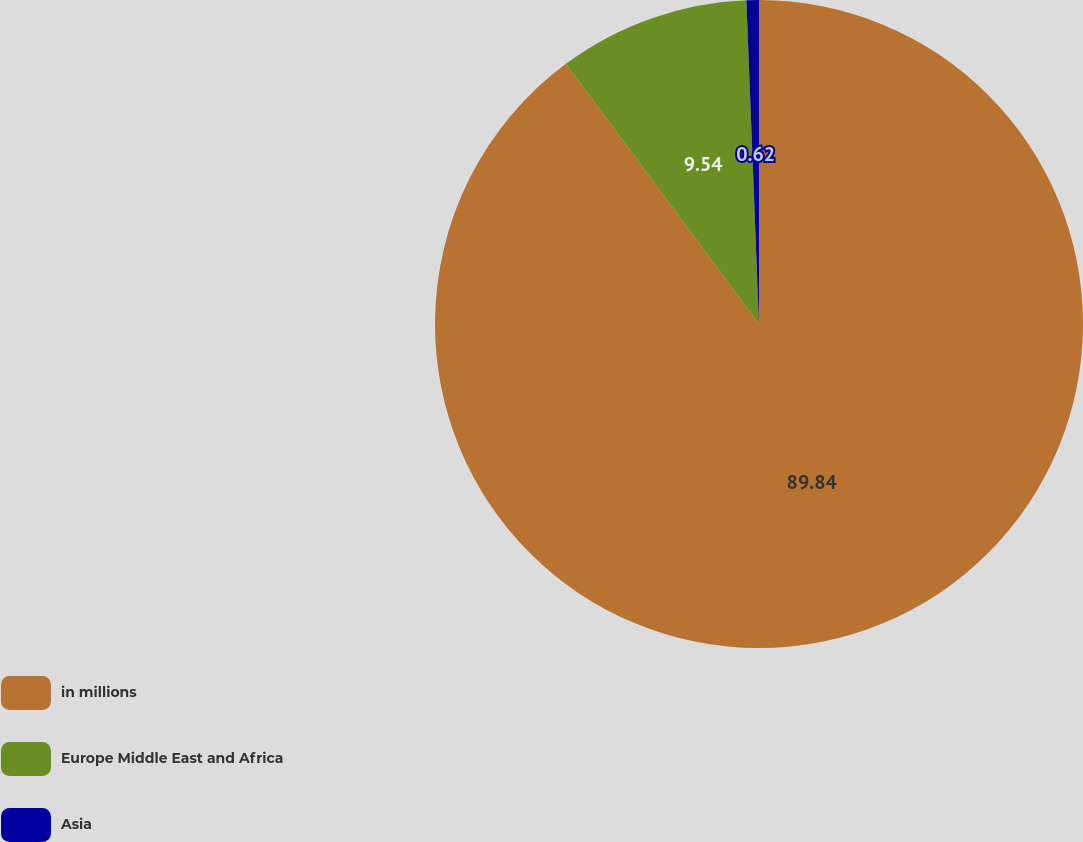<chart> <loc_0><loc_0><loc_500><loc_500><pie_chart><fcel>in millions<fcel>Europe Middle East and Africa<fcel>Asia<nl><fcel>89.83%<fcel>9.54%<fcel>0.62%<nl></chart> 